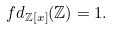<formula> <loc_0><loc_0><loc_500><loc_500>f d _ { \mathbb { Z } [ x ] } ( \mathbb { Z } ) = 1 .</formula> 